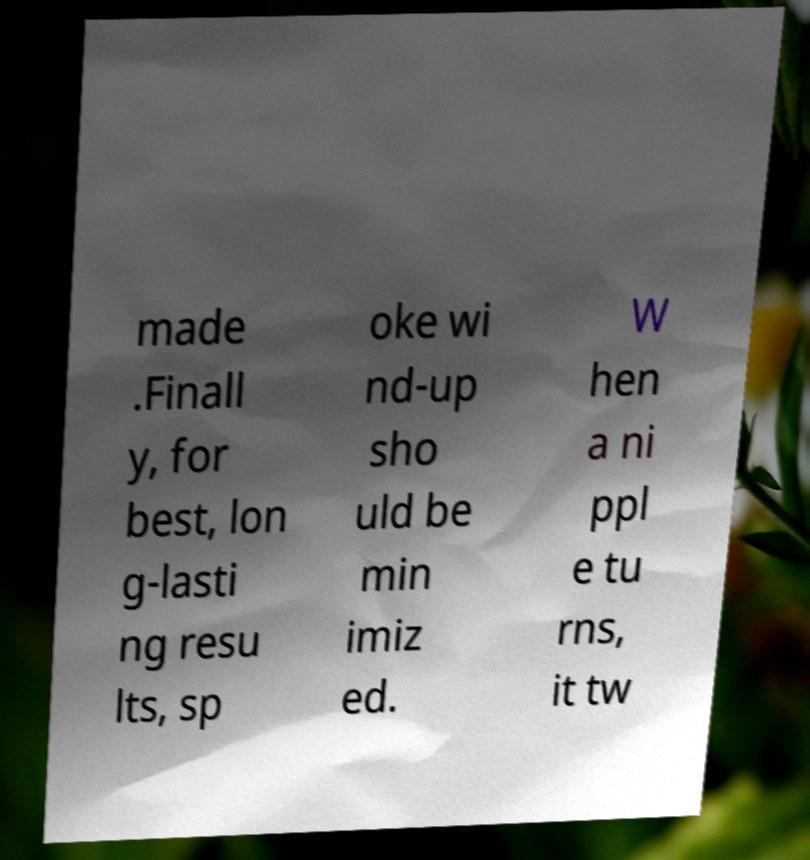I need the written content from this picture converted into text. Can you do that? made .Finall y, for best, lon g-lasti ng resu lts, sp oke wi nd-up sho uld be min imiz ed. W hen a ni ppl e tu rns, it tw 